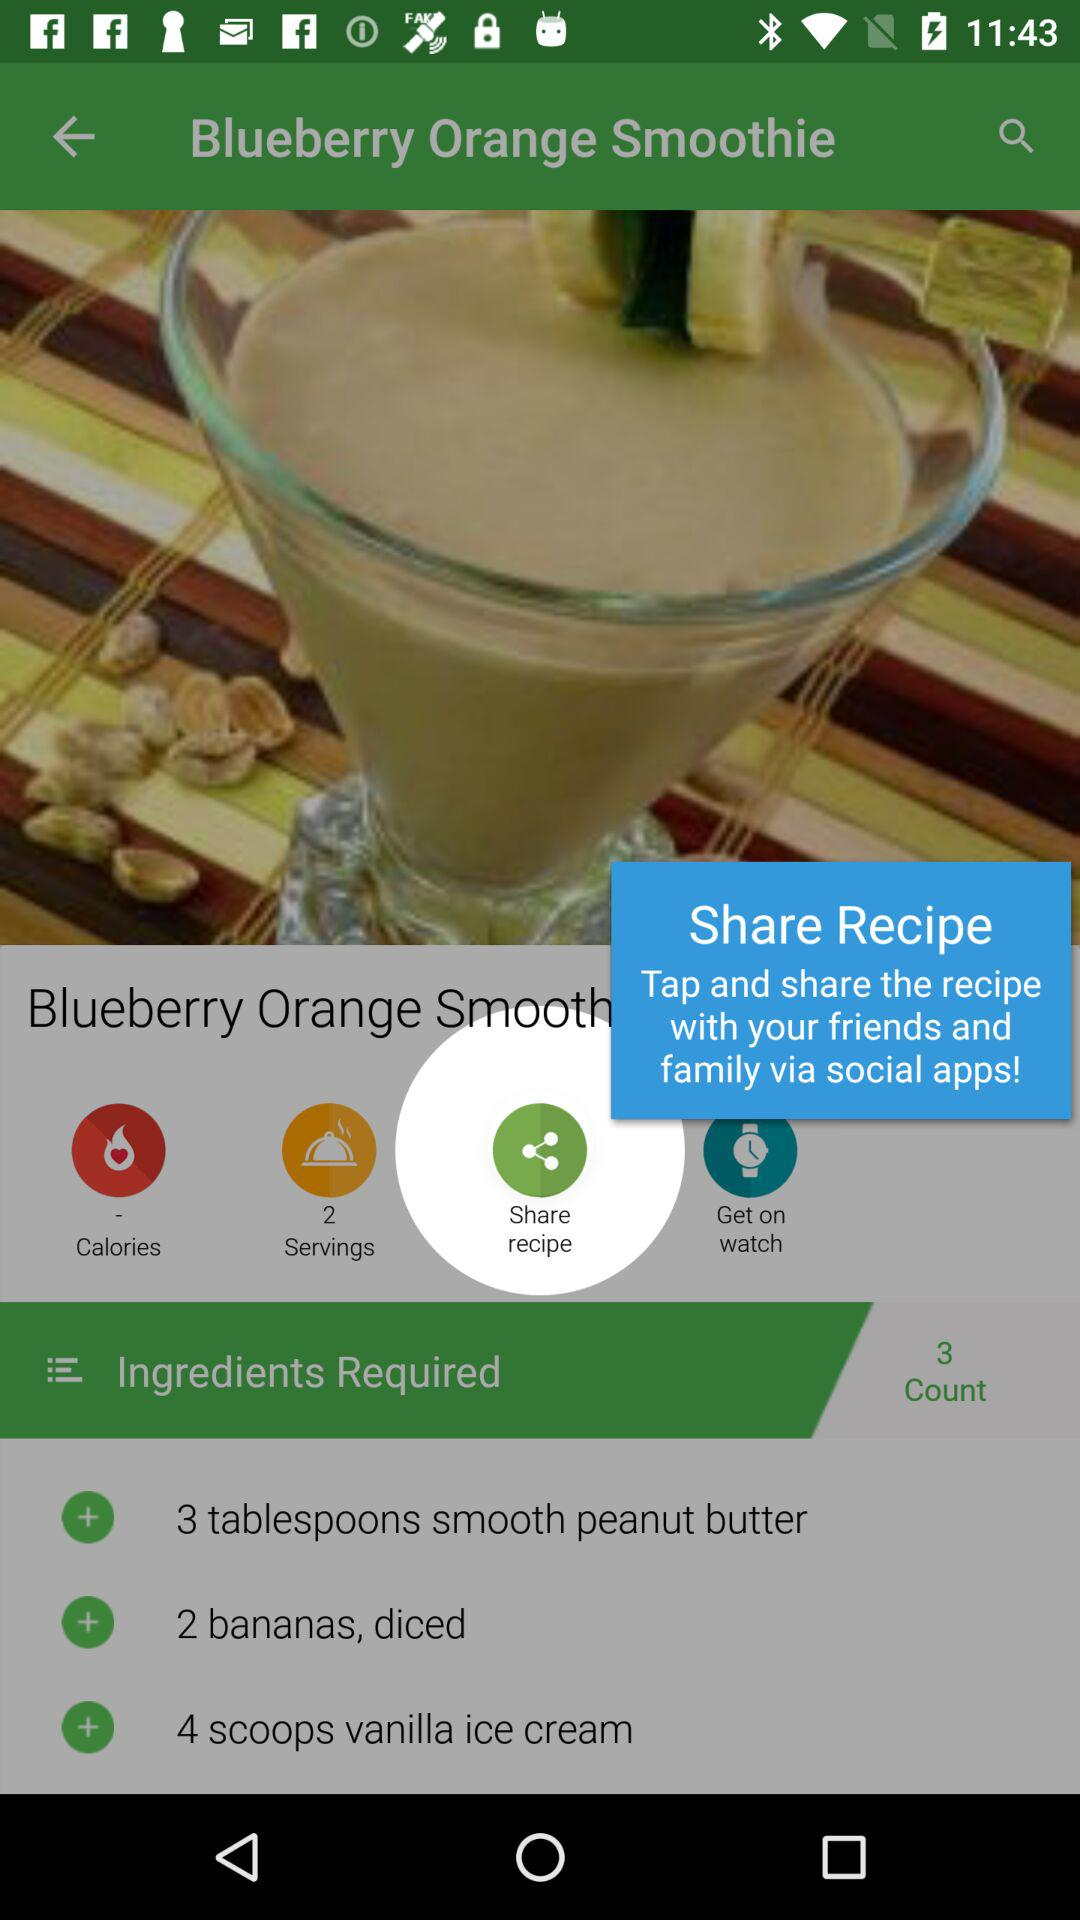How many people could be served? The people who could be served are 2. 